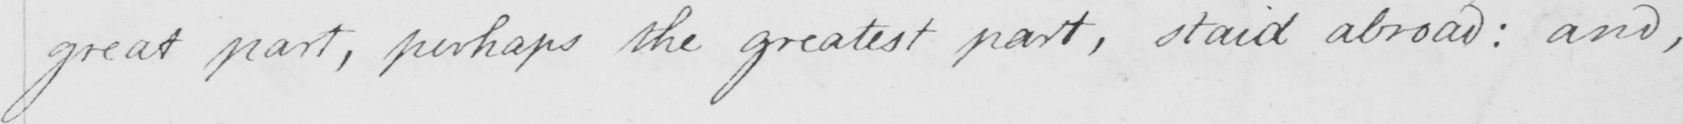Can you read and transcribe this handwriting? great part , perhaps the greatest part , staid abroad :  and , 